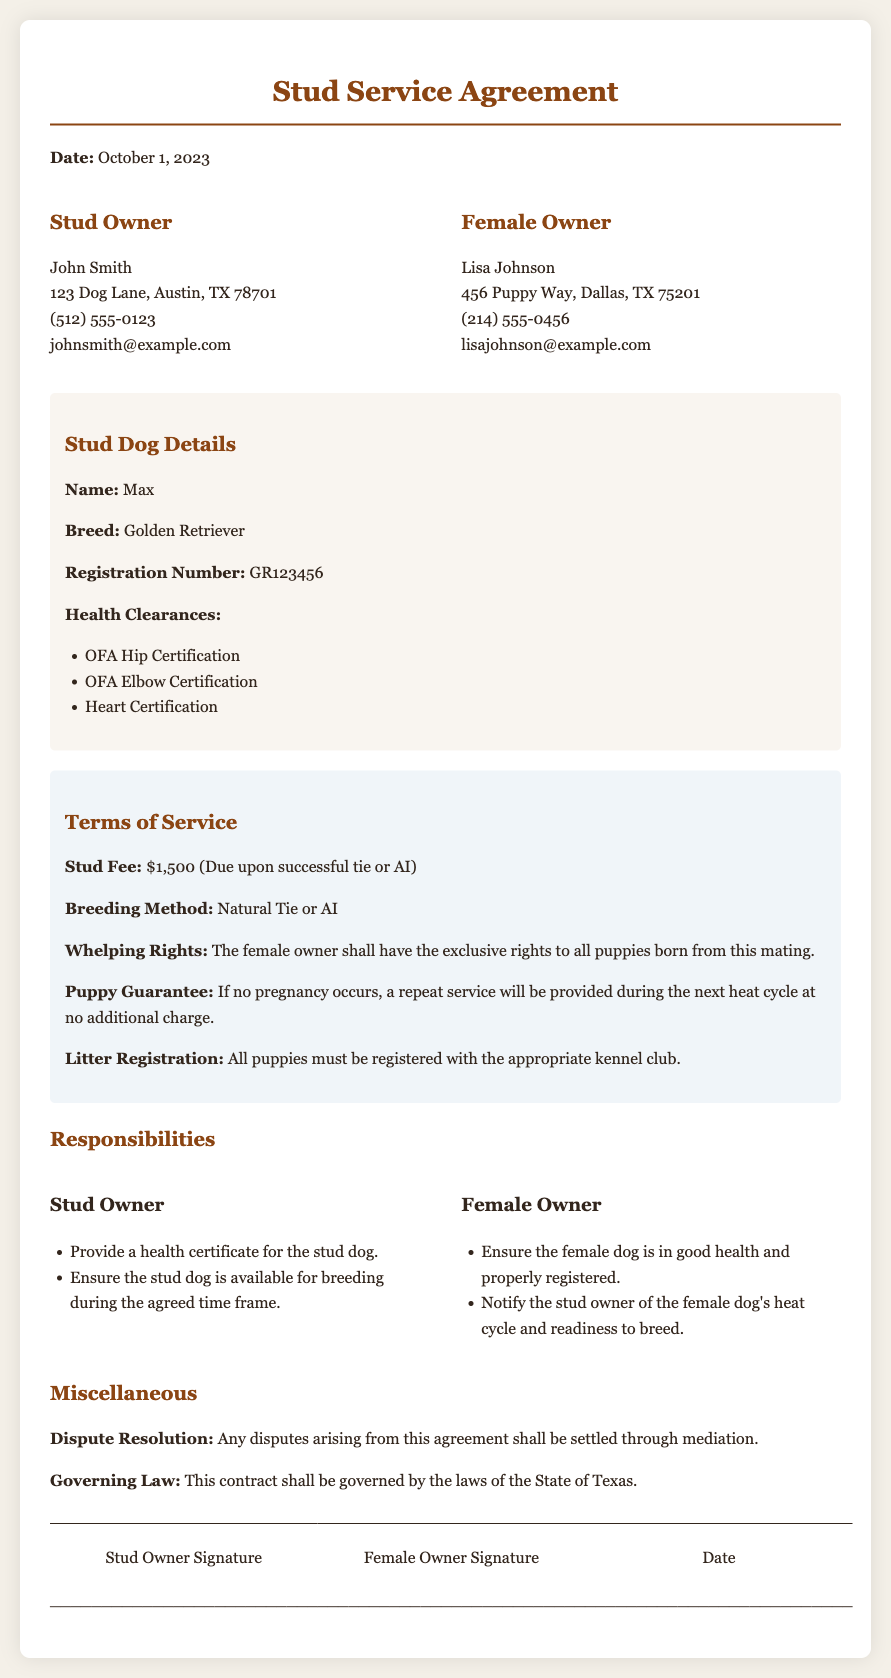what is the stud fee? The stud fee is mentioned as the payment required for the service, which is $1,500 (Due upon successful tie or AI).
Answer: $1,500 who is the stud owner? The document provides the name and contact information of the stud owner, which is John Smith.
Answer: John Smith what is the breed of the stud dog? The breed of the stud dog is listed in the dog details section of the document.
Answer: Golden Retriever what happens if no pregnancy occurs? The document outlines the guarantee regarding pregnancy, stating that a repeat service will be provided during the next heat cycle at no additional charge.
Answer: Repeat service during next heat cycle at no additional charge what is the governing law for the agreement? The governing law is specified in the miscellaneous section and states which legal jurisdiction applies to the contract.
Answer: Laws of the State of Texas which certifications are required for the stud dog? The document lists health clearances that the stud dog must possess, which includes OFA Hip Certification, OFA Elbow Certification, and Heart Certification.
Answer: OFA Hip Certification, OFA Elbow Certification, Heart Certification what must the female owner ensure about her dog? The document outlines responsibilities for the female owner, specifically ensuring that her dog is in good health and properly registered.
Answer: In good health and properly registered who provides the health certificate for the stud dog? The responsibilities section of the document notes who is responsible for providing the health certificate.
Answer: Stud Owner when is the stud fee due? The terms specify the timing for the payment of the stud fee in relation to the breeding process.
Answer: Upon successful tie or AI 